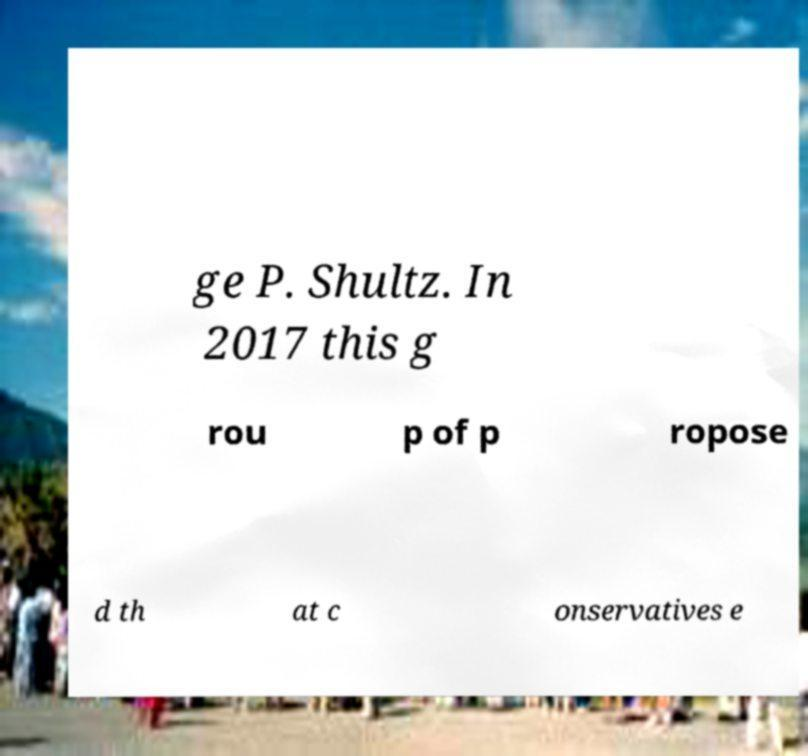I need the written content from this picture converted into text. Can you do that? ge P. Shultz. In 2017 this g rou p of p ropose d th at c onservatives e 